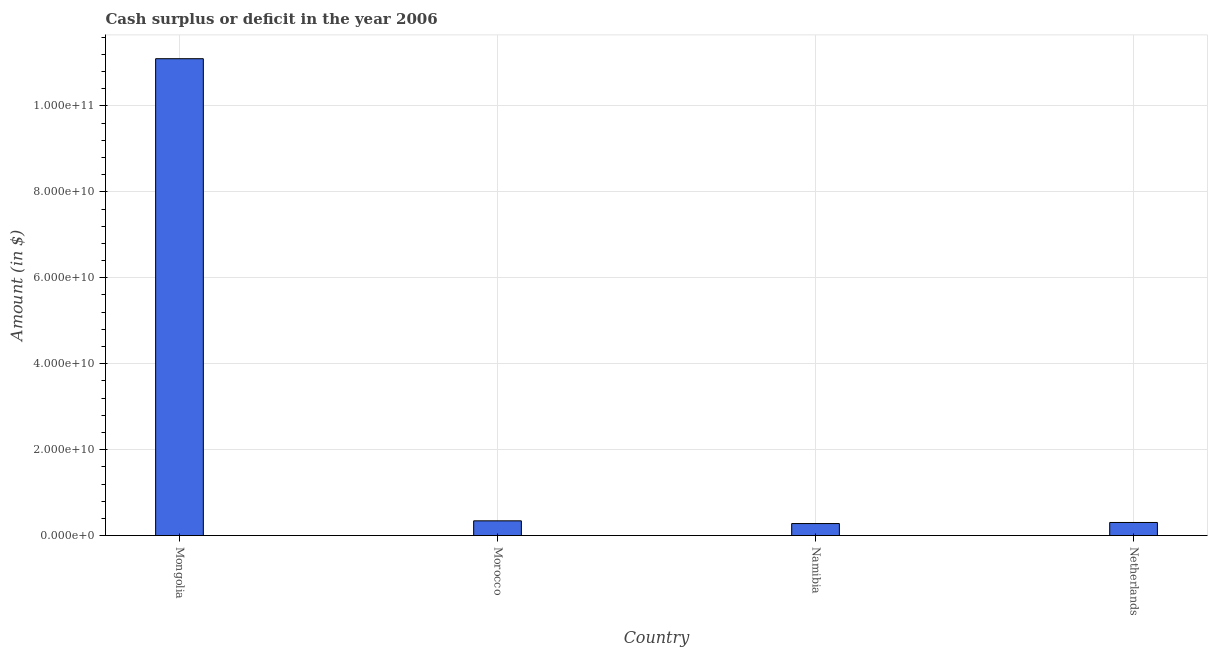Does the graph contain any zero values?
Your answer should be compact. No. Does the graph contain grids?
Make the answer very short. Yes. What is the title of the graph?
Provide a succinct answer. Cash surplus or deficit in the year 2006. What is the label or title of the X-axis?
Give a very brief answer. Country. What is the label or title of the Y-axis?
Make the answer very short. Amount (in $). What is the cash surplus or deficit in Morocco?
Keep it short and to the point. 3.43e+09. Across all countries, what is the maximum cash surplus or deficit?
Provide a short and direct response. 1.11e+11. Across all countries, what is the minimum cash surplus or deficit?
Your response must be concise. 2.79e+09. In which country was the cash surplus or deficit maximum?
Offer a very short reply. Mongolia. In which country was the cash surplus or deficit minimum?
Make the answer very short. Namibia. What is the sum of the cash surplus or deficit?
Your answer should be very brief. 1.20e+11. What is the difference between the cash surplus or deficit in Namibia and Netherlands?
Provide a short and direct response. -2.54e+08. What is the average cash surplus or deficit per country?
Ensure brevity in your answer.  3.01e+1. What is the median cash surplus or deficit?
Offer a very short reply. 3.24e+09. In how many countries, is the cash surplus or deficit greater than 52000000000 $?
Provide a succinct answer. 1. What is the ratio of the cash surplus or deficit in Namibia to that in Netherlands?
Ensure brevity in your answer.  0.92. What is the difference between the highest and the second highest cash surplus or deficit?
Make the answer very short. 1.08e+11. What is the difference between the highest and the lowest cash surplus or deficit?
Your answer should be compact. 1.08e+11. In how many countries, is the cash surplus or deficit greater than the average cash surplus or deficit taken over all countries?
Your response must be concise. 1. What is the difference between two consecutive major ticks on the Y-axis?
Your answer should be compact. 2.00e+1. Are the values on the major ticks of Y-axis written in scientific E-notation?
Provide a short and direct response. Yes. What is the Amount (in $) in Mongolia?
Give a very brief answer. 1.11e+11. What is the Amount (in $) of Morocco?
Keep it short and to the point. 3.43e+09. What is the Amount (in $) in Namibia?
Keep it short and to the point. 2.79e+09. What is the Amount (in $) in Netherlands?
Your response must be concise. 3.05e+09. What is the difference between the Amount (in $) in Mongolia and Morocco?
Provide a succinct answer. 1.08e+11. What is the difference between the Amount (in $) in Mongolia and Namibia?
Your answer should be compact. 1.08e+11. What is the difference between the Amount (in $) in Mongolia and Netherlands?
Offer a terse response. 1.08e+11. What is the difference between the Amount (in $) in Morocco and Namibia?
Your answer should be very brief. 6.35e+08. What is the difference between the Amount (in $) in Morocco and Netherlands?
Provide a short and direct response. 3.81e+08. What is the difference between the Amount (in $) in Namibia and Netherlands?
Provide a succinct answer. -2.54e+08. What is the ratio of the Amount (in $) in Mongolia to that in Morocco?
Keep it short and to the point. 32.37. What is the ratio of the Amount (in $) in Mongolia to that in Namibia?
Provide a short and direct response. 39.72. What is the ratio of the Amount (in $) in Mongolia to that in Netherlands?
Keep it short and to the point. 36.42. What is the ratio of the Amount (in $) in Morocco to that in Namibia?
Your answer should be compact. 1.23. What is the ratio of the Amount (in $) in Morocco to that in Netherlands?
Keep it short and to the point. 1.12. What is the ratio of the Amount (in $) in Namibia to that in Netherlands?
Your response must be concise. 0.92. 